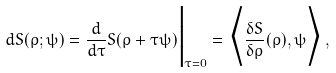<formula> <loc_0><loc_0><loc_500><loc_500>d S ( \rho ; \psi ) = \frac { d } { d \tau } S ( \rho + \tau \psi ) \Big | _ { \tau = 0 } = \Big \langle \frac { \delta S } { \delta \rho } ( \rho ) , \psi \Big \rangle \, ,</formula> 